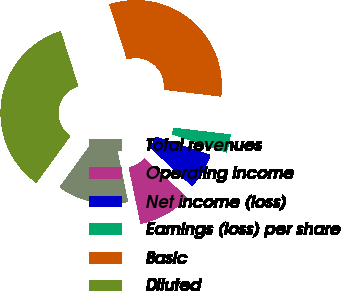<chart> <loc_0><loc_0><loc_500><loc_500><pie_chart><fcel>Total revenues<fcel>Operating income<fcel>Net income (loss)<fcel>Earnings (loss) per share<fcel>Basic<fcel>Diluted<nl><fcel>13.24%<fcel>9.93%<fcel>6.62%<fcel>3.31%<fcel>31.79%<fcel>35.1%<nl></chart> 